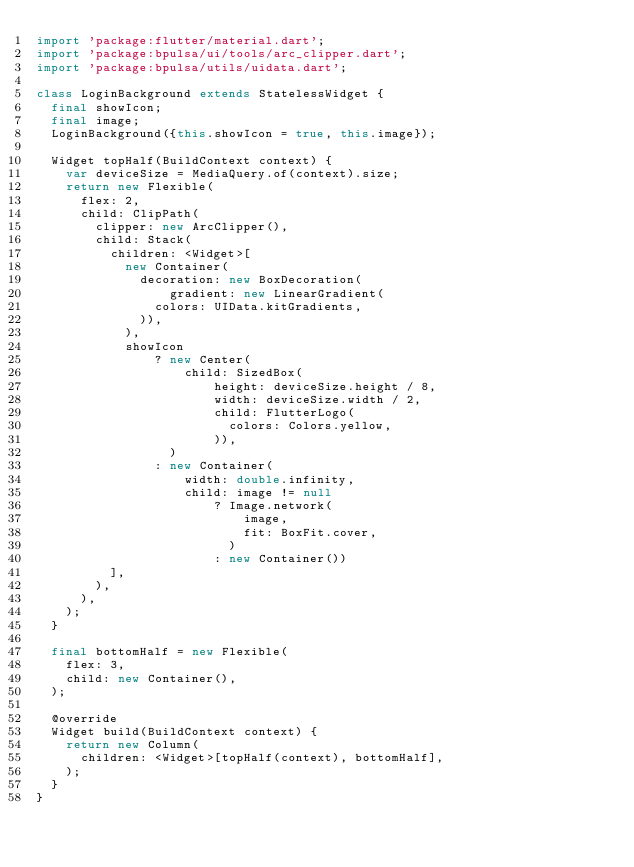Convert code to text. <code><loc_0><loc_0><loc_500><loc_500><_Dart_>import 'package:flutter/material.dart';
import 'package:bpulsa/ui/tools/arc_clipper.dart';
import 'package:bpulsa/utils/uidata.dart';

class LoginBackground extends StatelessWidget {
  final showIcon;
  final image;
  LoginBackground({this.showIcon = true, this.image});

  Widget topHalf(BuildContext context) {
    var deviceSize = MediaQuery.of(context).size;
    return new Flexible(
      flex: 2,
      child: ClipPath(
        clipper: new ArcClipper(),
        child: Stack(
          children: <Widget>[
            new Container(
              decoration: new BoxDecoration(
                  gradient: new LinearGradient(
                colors: UIData.kitGradients,
              )),
            ),
            showIcon
                ? new Center(
                    child: SizedBox(
                        height: deviceSize.height / 8,
                        width: deviceSize.width / 2,
                        child: FlutterLogo(
                          colors: Colors.yellow,
                        )),
                  )
                : new Container(
                    width: double.infinity,
                    child: image != null
                        ? Image.network(
                            image,
                            fit: BoxFit.cover,
                          )
                        : new Container())
          ],
        ),
      ),
    );
  }

  final bottomHalf = new Flexible(
    flex: 3,
    child: new Container(),
  );

  @override
  Widget build(BuildContext context) {
    return new Column(
      children: <Widget>[topHalf(context), bottomHalf],
    );
  }
}
</code> 